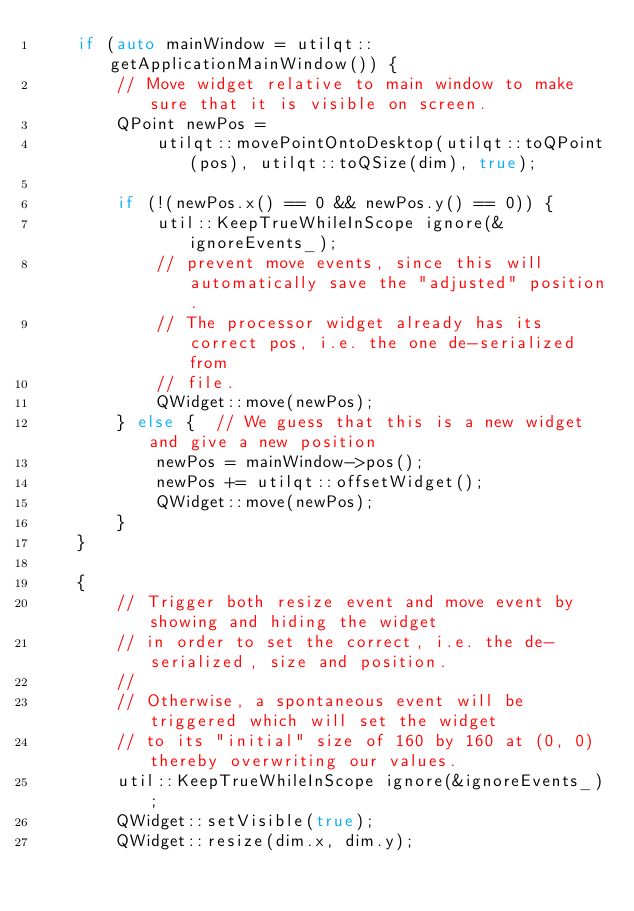<code> <loc_0><loc_0><loc_500><loc_500><_C++_>    if (auto mainWindow = utilqt::getApplicationMainWindow()) {
        // Move widget relative to main window to make sure that it is visible on screen.
        QPoint newPos =
            utilqt::movePointOntoDesktop(utilqt::toQPoint(pos), utilqt::toQSize(dim), true);

        if (!(newPos.x() == 0 && newPos.y() == 0)) {
            util::KeepTrueWhileInScope ignore(&ignoreEvents_);
            // prevent move events, since this will automatically save the "adjusted" position.
            // The processor widget already has its correct pos, i.e. the one de-serialized from
            // file.
            QWidget::move(newPos);
        } else {  // We guess that this is a new widget and give a new position
            newPos = mainWindow->pos();
            newPos += utilqt::offsetWidget();
            QWidget::move(newPos);
        }
    }

    {
        // Trigger both resize event and move event by showing and hiding the widget
        // in order to set the correct, i.e. the de-serialized, size and position.
        //
        // Otherwise, a spontaneous event will be triggered which will set the widget
        // to its "initial" size of 160 by 160 at (0, 0) thereby overwriting our values.
        util::KeepTrueWhileInScope ignore(&ignoreEvents_);
        QWidget::setVisible(true);
        QWidget::resize(dim.x, dim.y);</code> 